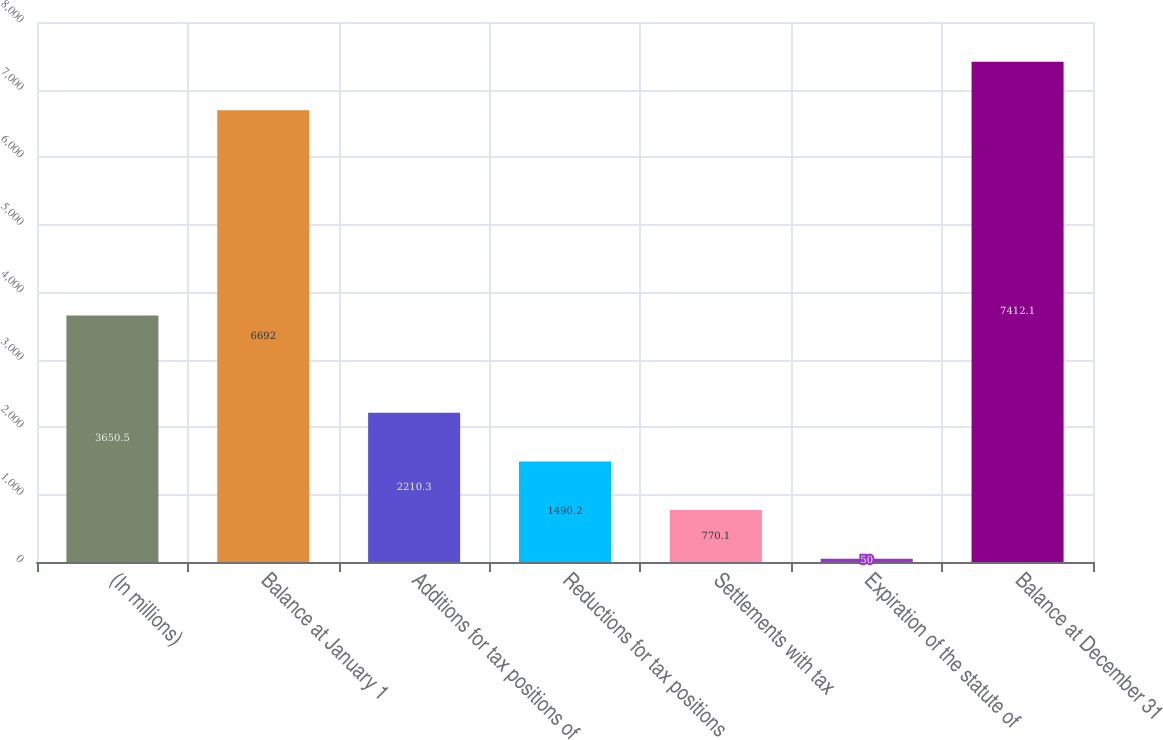Convert chart. <chart><loc_0><loc_0><loc_500><loc_500><bar_chart><fcel>(In millions)<fcel>Balance at January 1<fcel>Additions for tax positions of<fcel>Reductions for tax positions<fcel>Settlements with tax<fcel>Expiration of the statute of<fcel>Balance at December 31<nl><fcel>3650.5<fcel>6692<fcel>2210.3<fcel>1490.2<fcel>770.1<fcel>50<fcel>7412.1<nl></chart> 